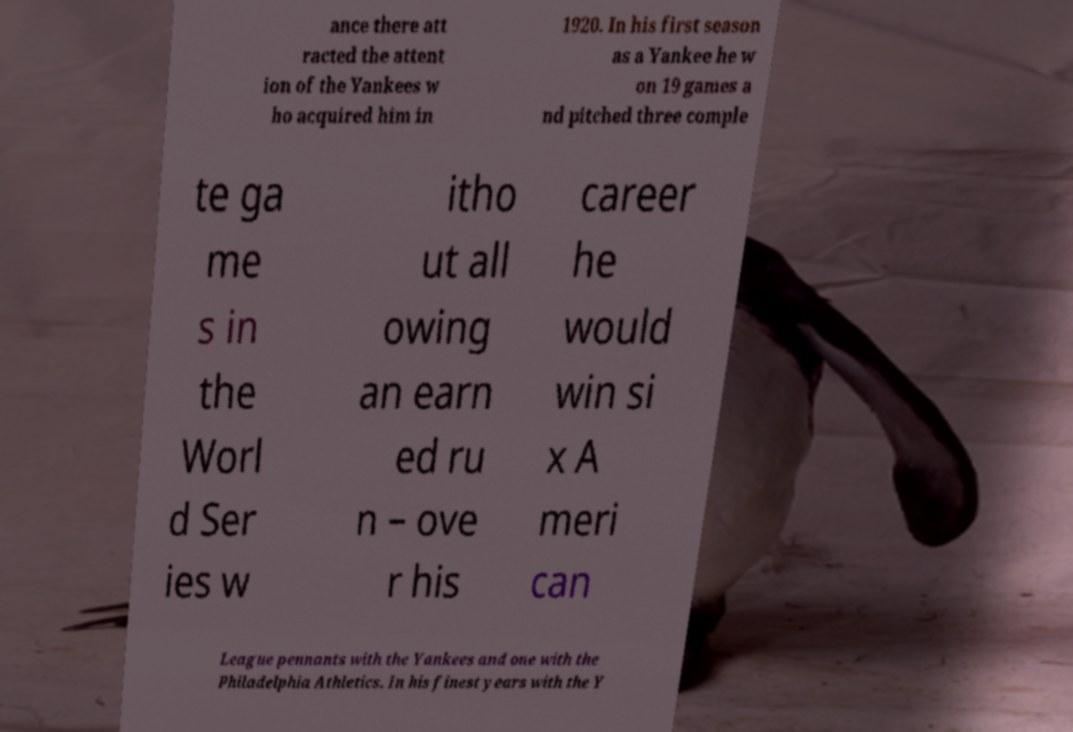For documentation purposes, I need the text within this image transcribed. Could you provide that? ance there att racted the attent ion of the Yankees w ho acquired him in 1920. In his first season as a Yankee he w on 19 games a nd pitched three comple te ga me s in the Worl d Ser ies w itho ut all owing an earn ed ru n – ove r his career he would win si x A meri can League pennants with the Yankees and one with the Philadelphia Athletics. In his finest years with the Y 